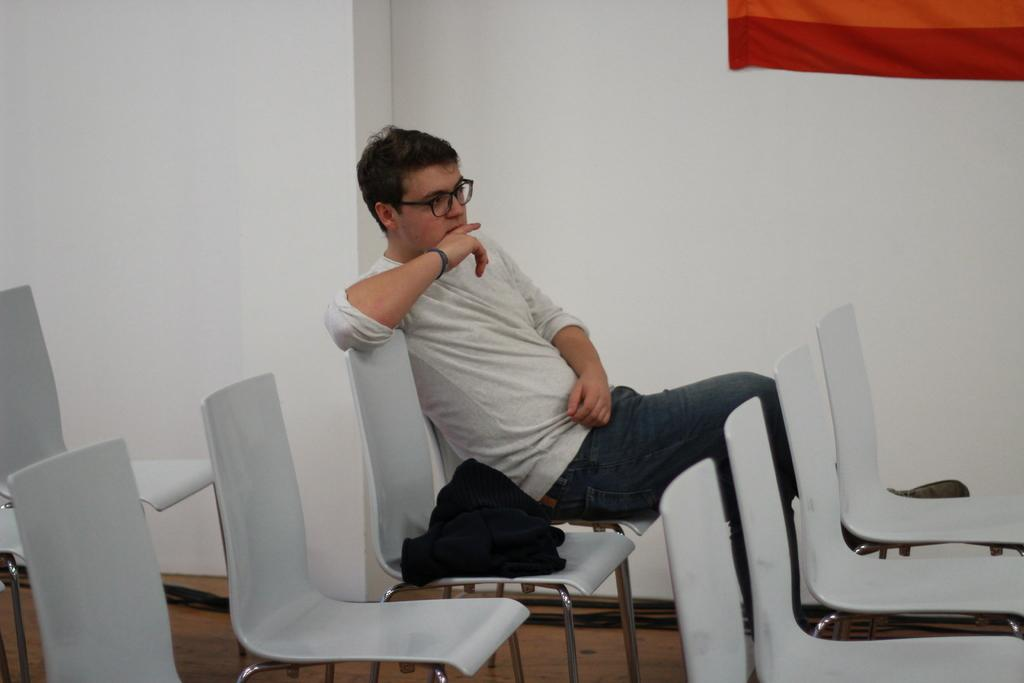What type of space is depicted in the image? There is a room in the image. What is the person in the room doing? A person is sitting in a chair in the room. Can you describe the person's appearance? The person is wearing spectacles. What type of notebook is the monkey holding in the image? There is no monkey or notebook present in the image. 